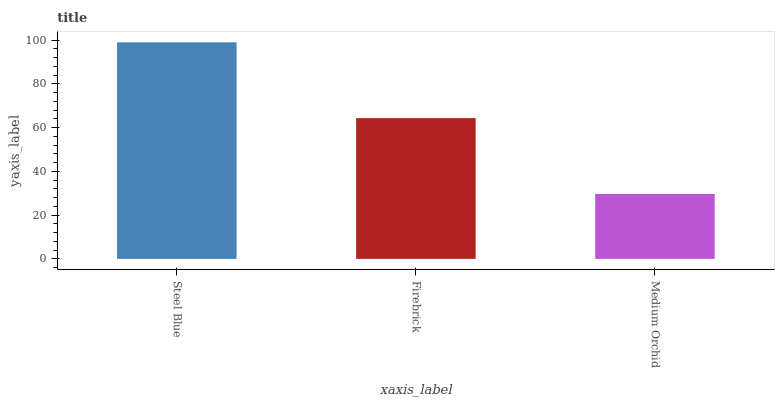Is Medium Orchid the minimum?
Answer yes or no. Yes. Is Steel Blue the maximum?
Answer yes or no. Yes. Is Firebrick the minimum?
Answer yes or no. No. Is Firebrick the maximum?
Answer yes or no. No. Is Steel Blue greater than Firebrick?
Answer yes or no. Yes. Is Firebrick less than Steel Blue?
Answer yes or no. Yes. Is Firebrick greater than Steel Blue?
Answer yes or no. No. Is Steel Blue less than Firebrick?
Answer yes or no. No. Is Firebrick the high median?
Answer yes or no. Yes. Is Firebrick the low median?
Answer yes or no. Yes. Is Steel Blue the high median?
Answer yes or no. No. Is Steel Blue the low median?
Answer yes or no. No. 